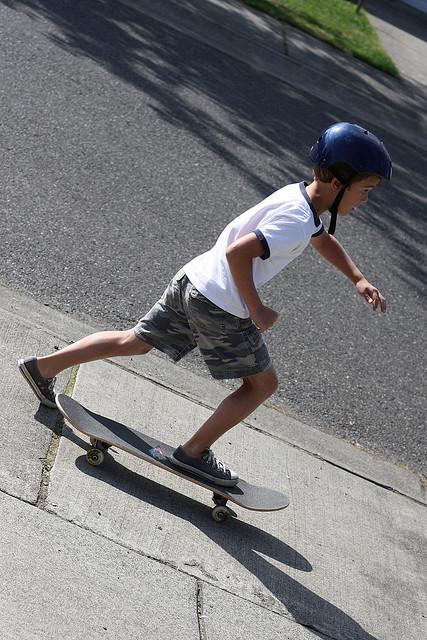What is the floor made out of?
Keep it brief. Concrete. Is this person about to fall?
Keep it brief. No. Is the boy safe?
Quick response, please. Yes. Is the boy wearing a hat?
Short answer required. Yes. Why is the boy's foot touching the ground?
Quick response, please. To push. 